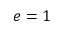Convert formula to latex. <formula><loc_0><loc_0><loc_500><loc_500>e = 1</formula> 